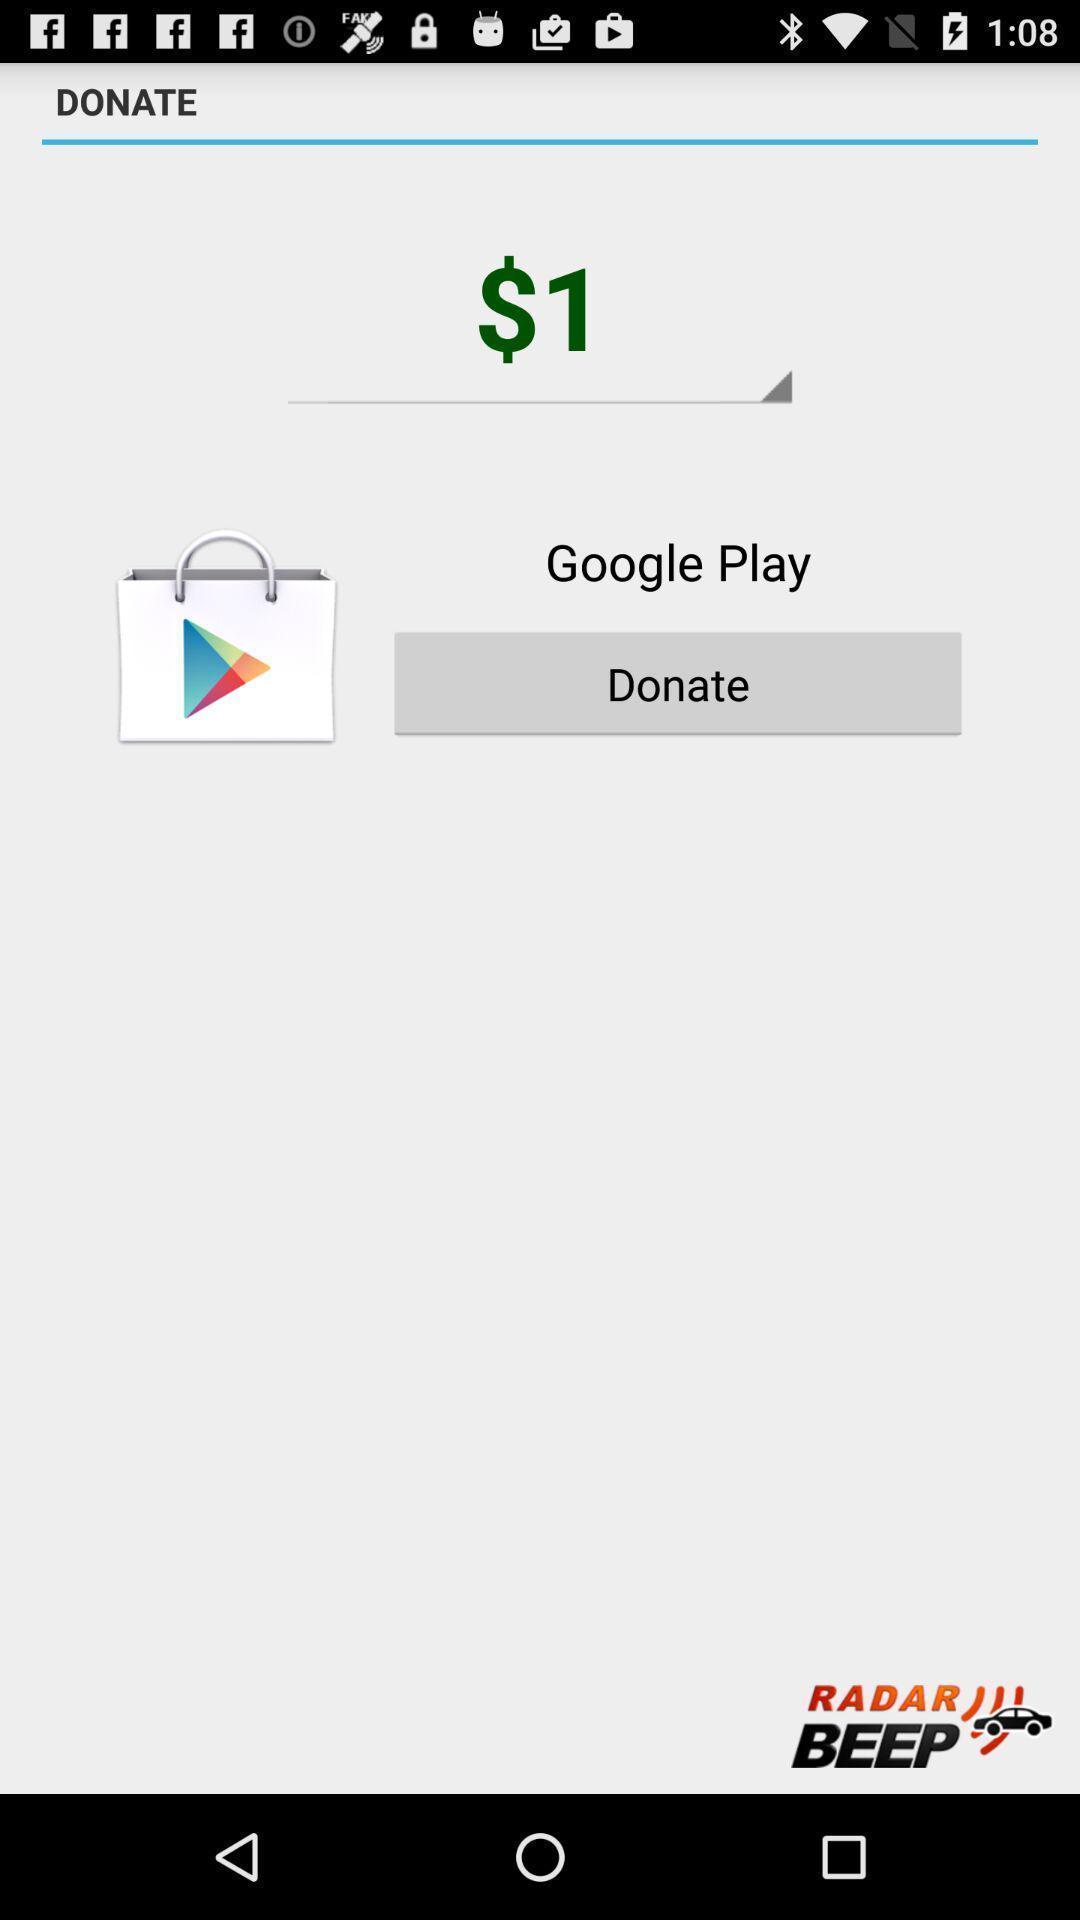What can you discern from this picture? Screen showing the amount for donating an app. 